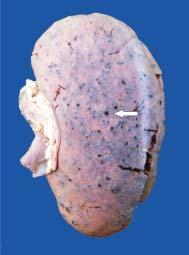what is enlarged in size and weight?
Answer the question using a single word or phrase. Kidney 